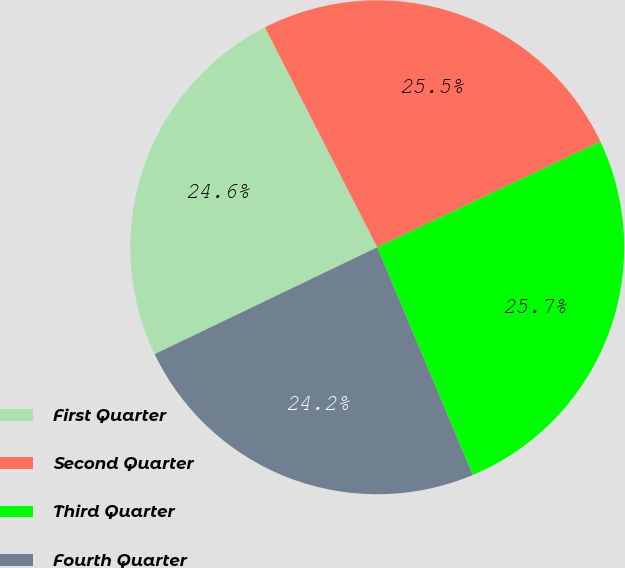<chart> <loc_0><loc_0><loc_500><loc_500><pie_chart><fcel>First Quarter<fcel>Second Quarter<fcel>Third Quarter<fcel>Fourth Quarter<nl><fcel>24.61%<fcel>25.48%<fcel>25.71%<fcel>24.2%<nl></chart> 